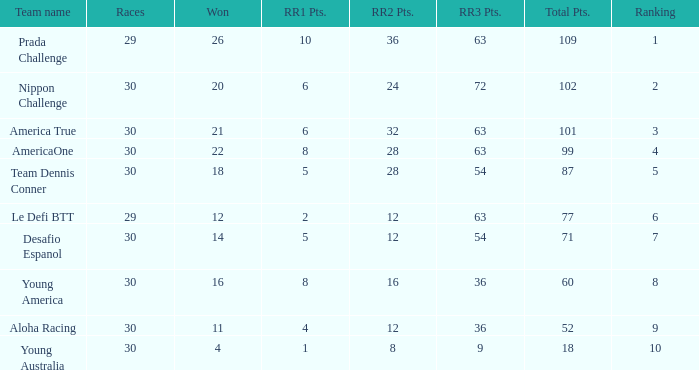Name the most rr1 pts for 7 ranking 5.0. 